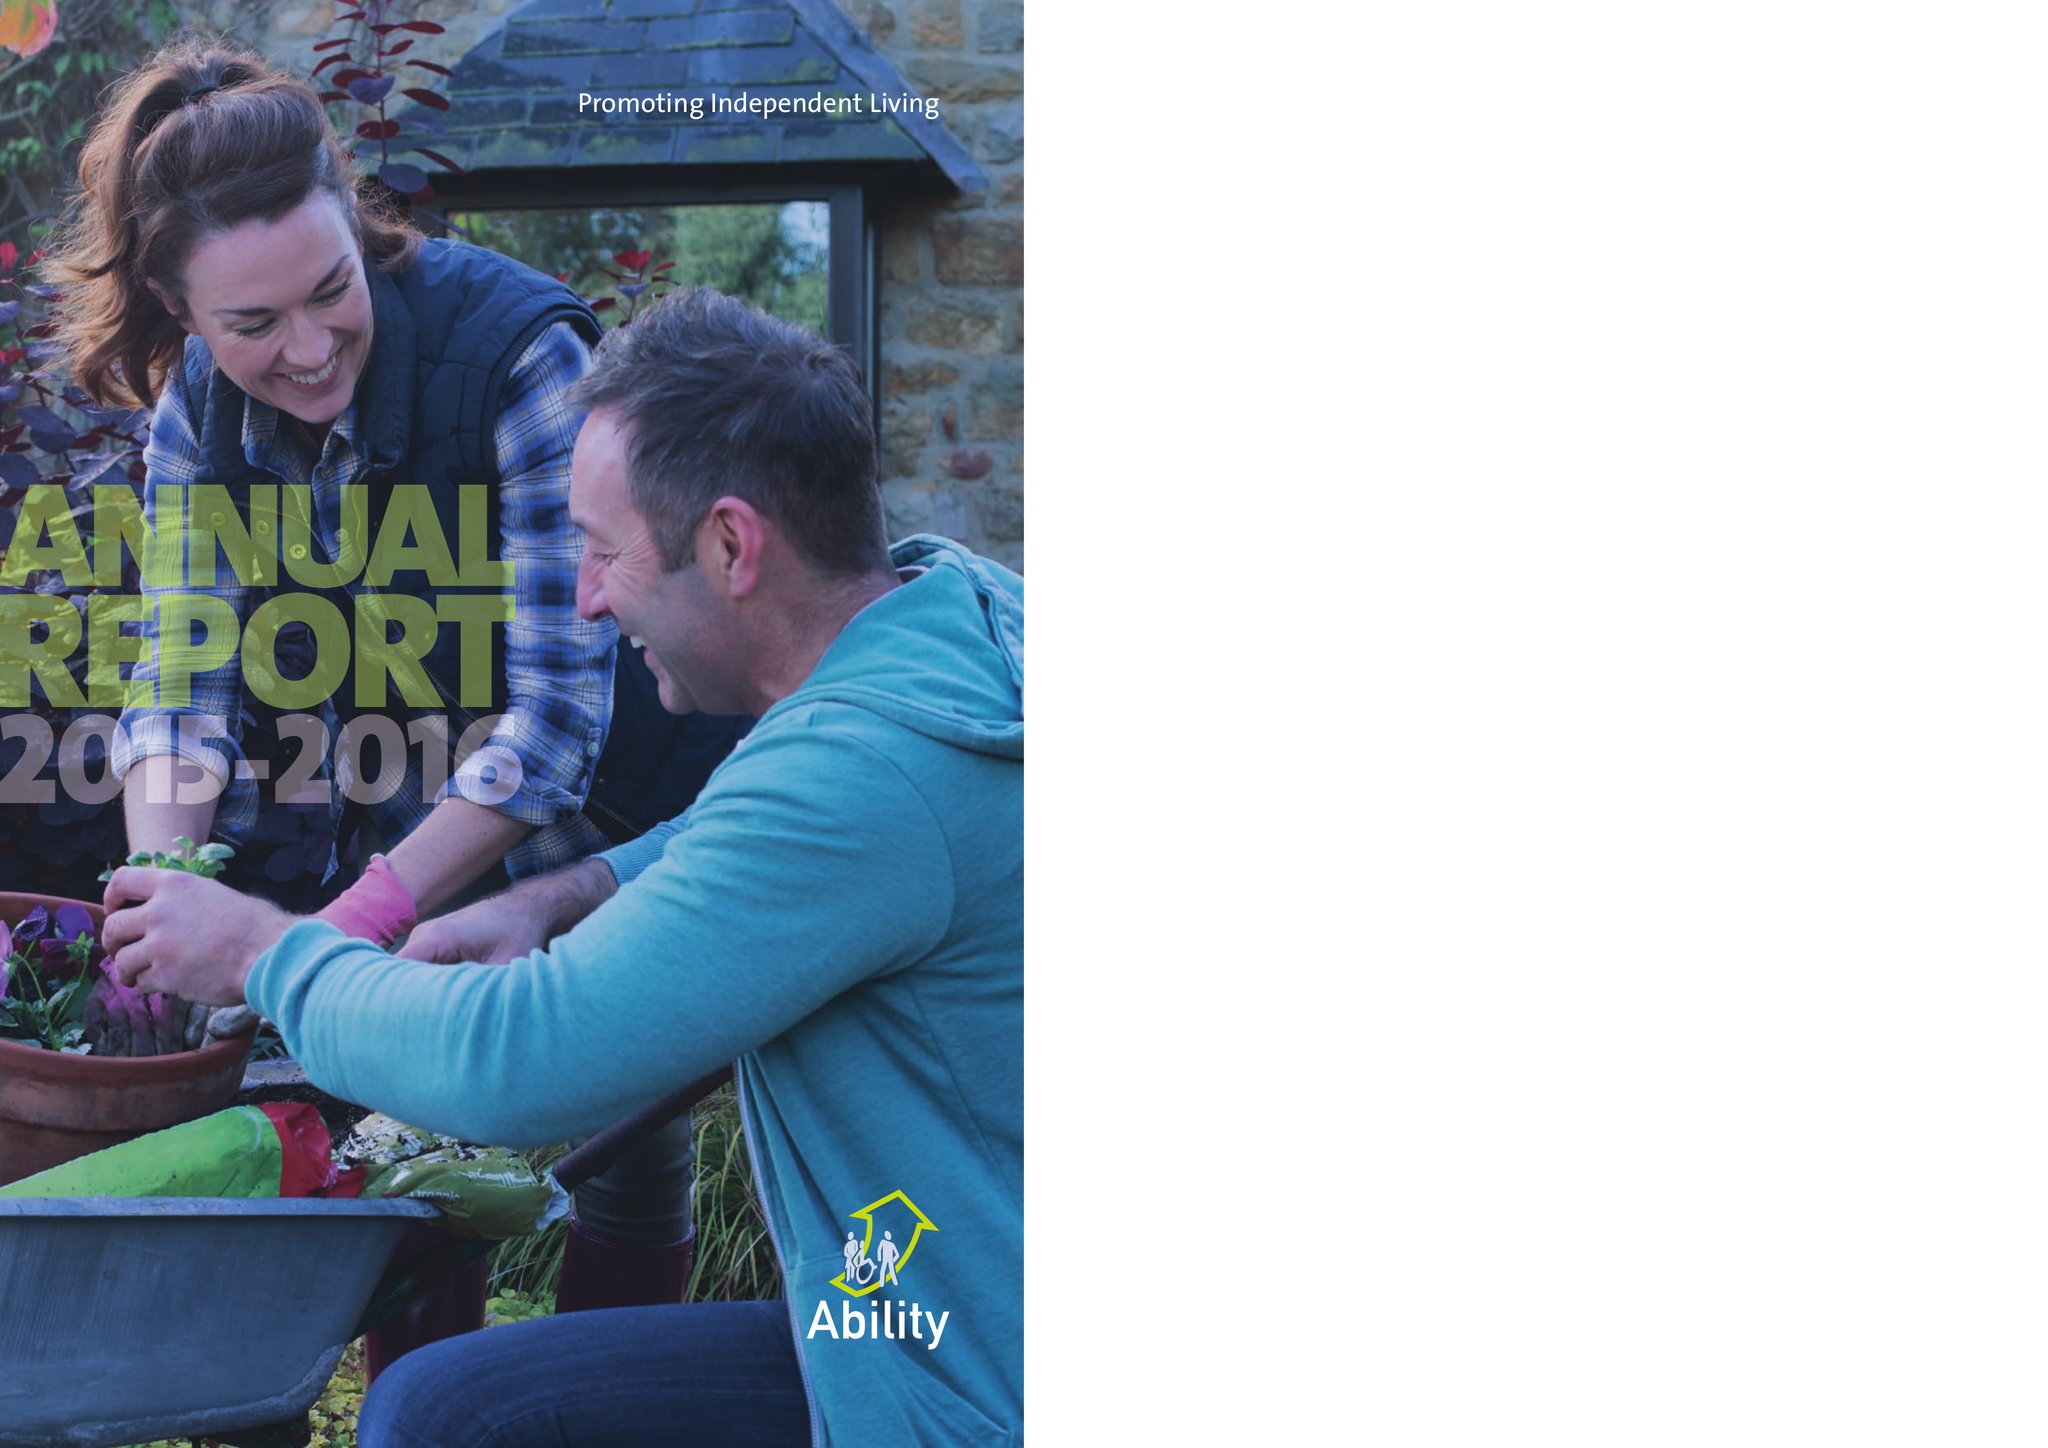What is the value for the spending_annually_in_british_pounds?
Answer the question using a single word or phrase. 9314006.00 